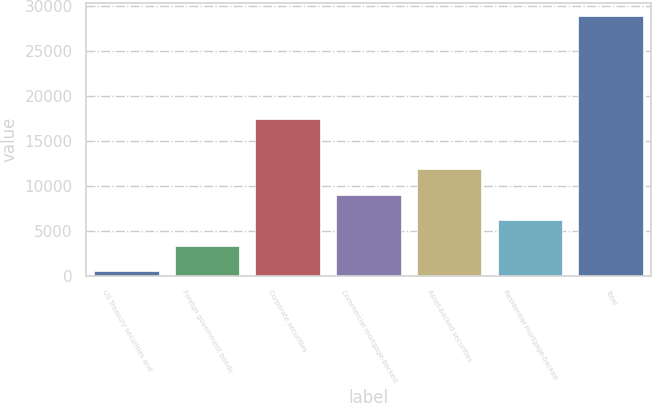<chart> <loc_0><loc_0><loc_500><loc_500><bar_chart><fcel>US Treasury securities and<fcel>Foreign government bonds<fcel>Corporate securities<fcel>Commercial mortgage-backed<fcel>Asset-backed securities<fcel>Residential mortgage-backed<fcel>Total<nl><fcel>475<fcel>3316.3<fcel>17414<fcel>8998.9<fcel>11840.2<fcel>6157.6<fcel>28888<nl></chart> 